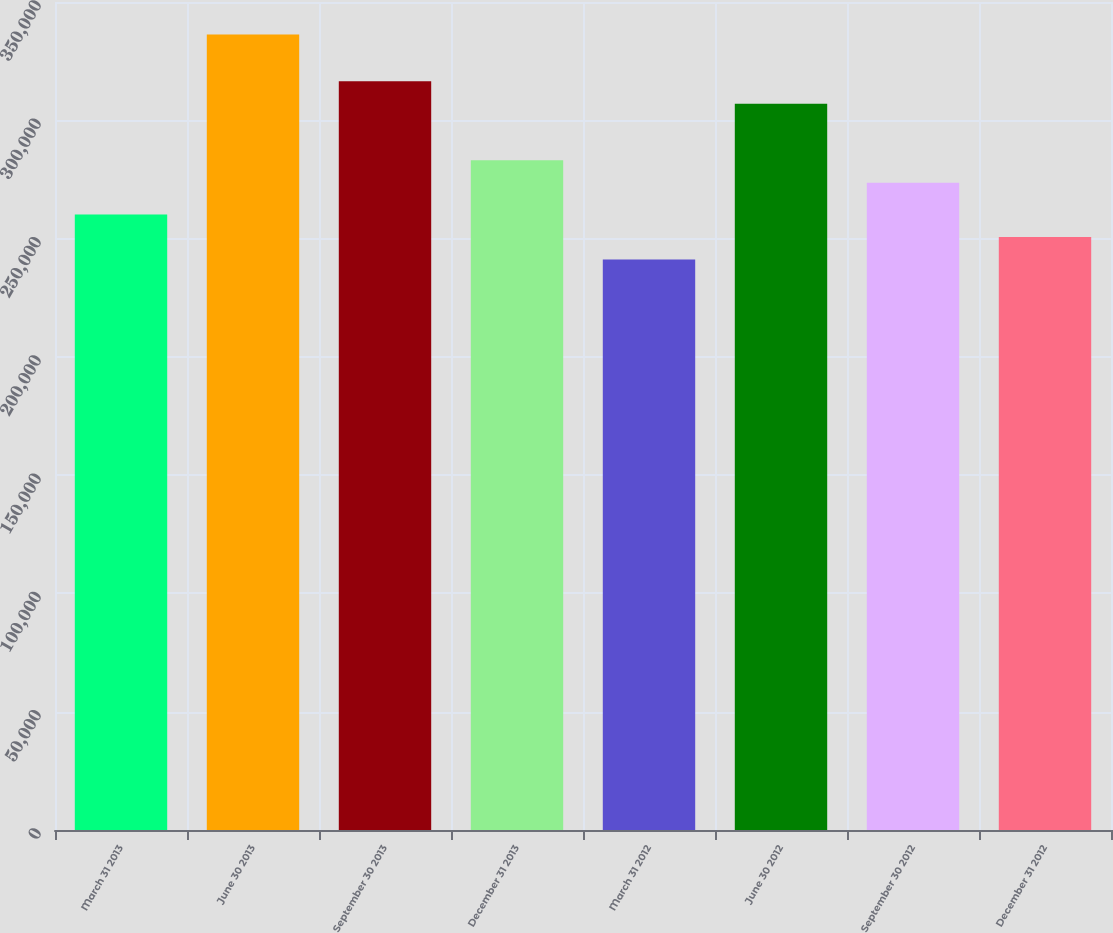Convert chart. <chart><loc_0><loc_0><loc_500><loc_500><bar_chart><fcel>March 31 2013<fcel>June 30 2013<fcel>September 30 2013<fcel>December 31 2013<fcel>March 31 2012<fcel>June 30 2012<fcel>September 30 2012<fcel>December 31 2012<nl><fcel>260188<fcel>336262<fcel>316517<fcel>283101<fcel>241169<fcel>307008<fcel>273592<fcel>250678<nl></chart> 